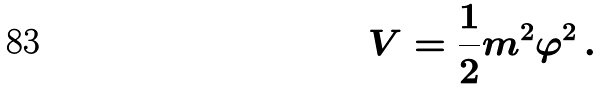Convert formula to latex. <formula><loc_0><loc_0><loc_500><loc_500>V = \frac { 1 } { 2 } m ^ { 2 } \varphi ^ { 2 } \, .</formula> 